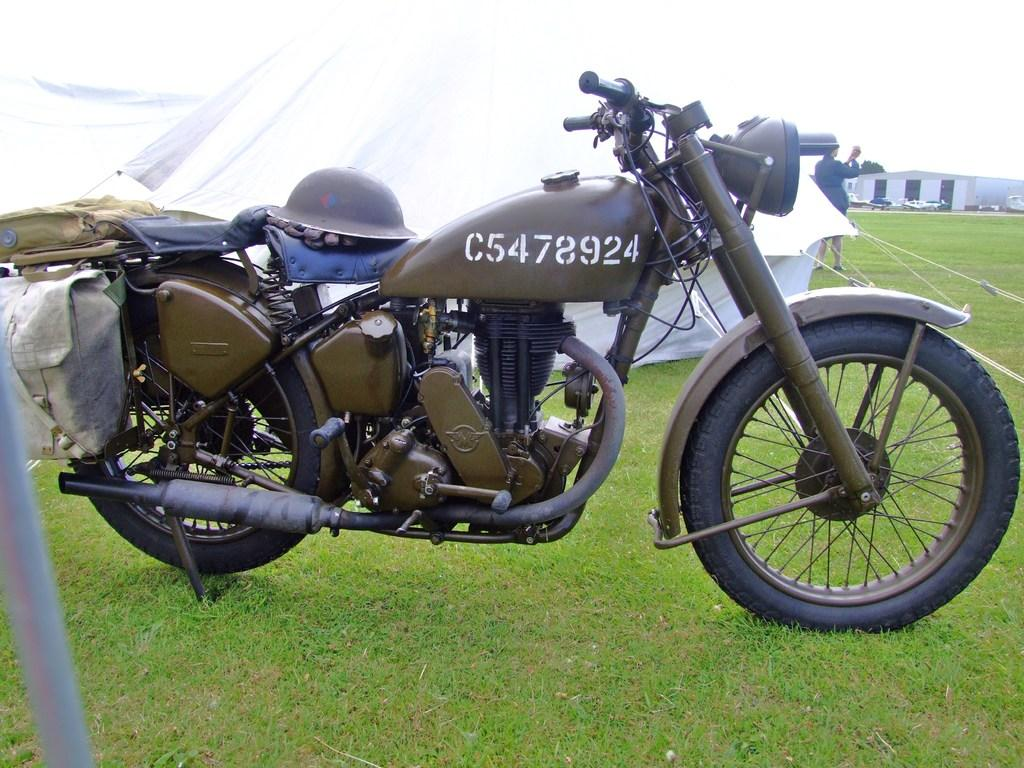What is attached to the bike in the image? There are bags on the bike. What type of headwear is on the bike? There is a cap on the bike. What can be seen in the background of the image? There are tents and a shed in the background. What is the person in the background doing? The person in the background is not visible in the image. What is visible at the bottom of the image? The ground is visible at the bottom of the image. What direction is the peace sign pointing in the image? There is no peace sign present in the image. What type of things are being carried by the person in the background? The person in the background is not visible in the image, so it is not possible to determine what they might be carrying. 